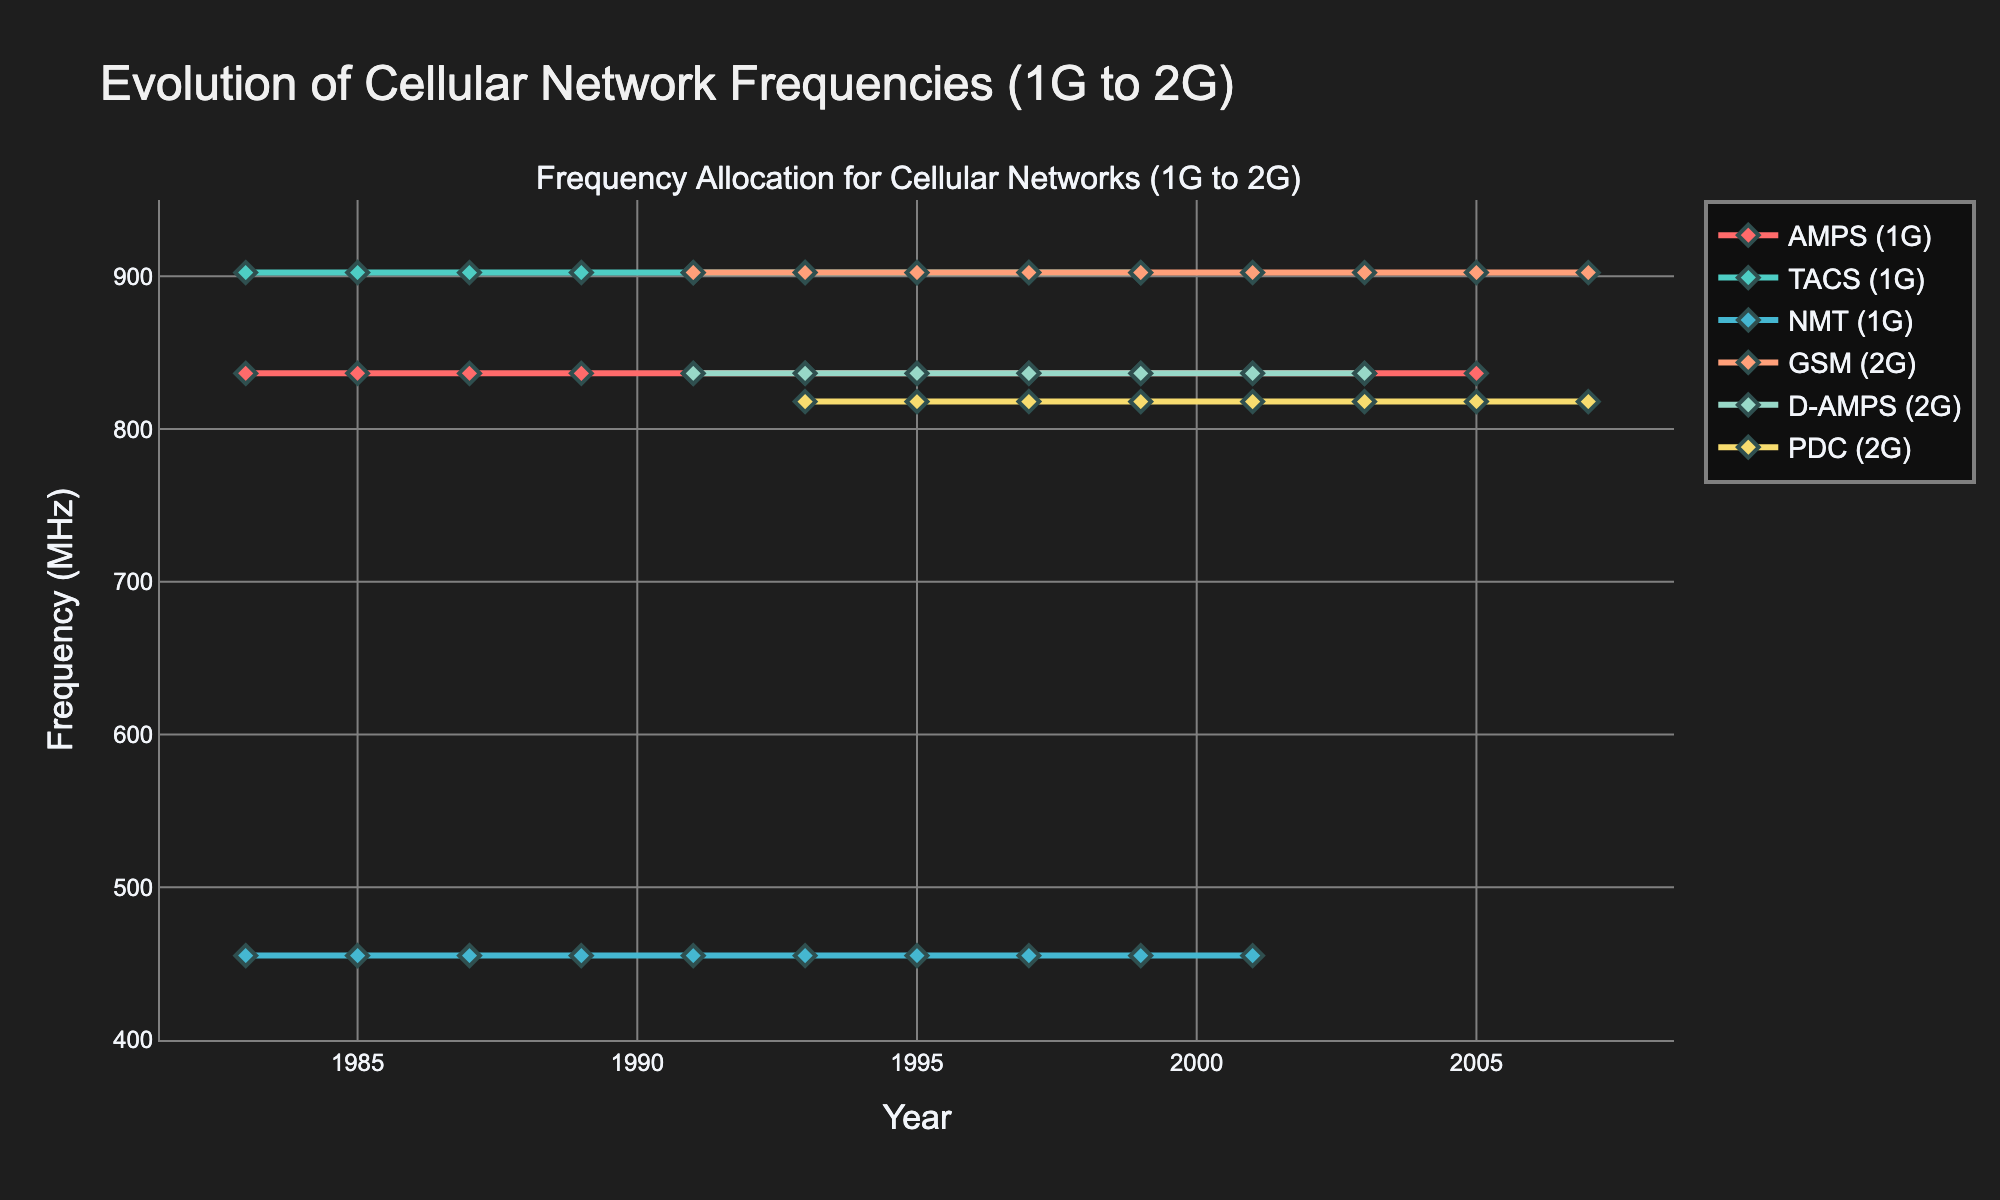When did GSM frequencies first appear in the chart? GSM frequencies first appear when the data line for GSM (2G) begins to show values. In the chart, this occurs in 1991.
Answer: 1991 What is the difference in frequency range between AMPS (1G) and GSM (2G) in 1991? In 1991, AMPS (1G) has a frequency range centered at 836.5 MHz (the average of 824-849 MHz) and GSM (2G) has a range centered at 902.5 MHz (the average of 890-915 MHz). The difference is 902.5 - 836.5 = 66 MHz.
Answer: 66 MHz Which system had its frequency range discontinued first, TACS (1G) or NMT (1G)? By inspecting the chart, TACS (1G) shows frequencies until 2001, while NMT (1G) frequencies are also present until 2001. Since they both were discontinued in the same year, no one system was discontinued first.
Answer: Both in 2001 In which year did both AMPS (1G) and D-AMPS (2G) systems operate simultaneously? AMPS (1G) and D-AMPS (2G) appeared together when the lines for both systems are present in the same year. This happens from 1991 up to 2005.
Answer: 1991-2005 How many systems were operating in 1995, and which ones were they? By examining the 1995 data points on the chart, we see that AMPS (1G), TACS (1G), NMT (1G), GSM (2G), D-AMPS (2G), and PDC (2G) were all operating. Counting them gives a total of 6 systems.
Answer: 6 systems: AMPS, TACS, NMT, GSM, D-AMPS, PDC What visual color is used for the NMT (1G) system? The color used for NMT (1G) can be identified from the chart legend. NMT (1G) is represented by a teal-like color in the figure.
Answer: Teal Which system's frequencies remained constant throughout their entire operation period? Analyzing the chart, the frequencies for AMPS (1G), NMT (1G), and GSM (2G) remain constant throughout their existence, but only AMPS (1G) from the start remained constant without any changes throughout its entire operation period.
Answer: AMPS (1G) What is the average frequency of PDC (2G) in 1997? In 1997, the frequency range for PDC (2G) is 810-826 MHz. The average frequency is calculated as (810 + 826) / 2 = 818 MHz.
Answer: 818 MHz 